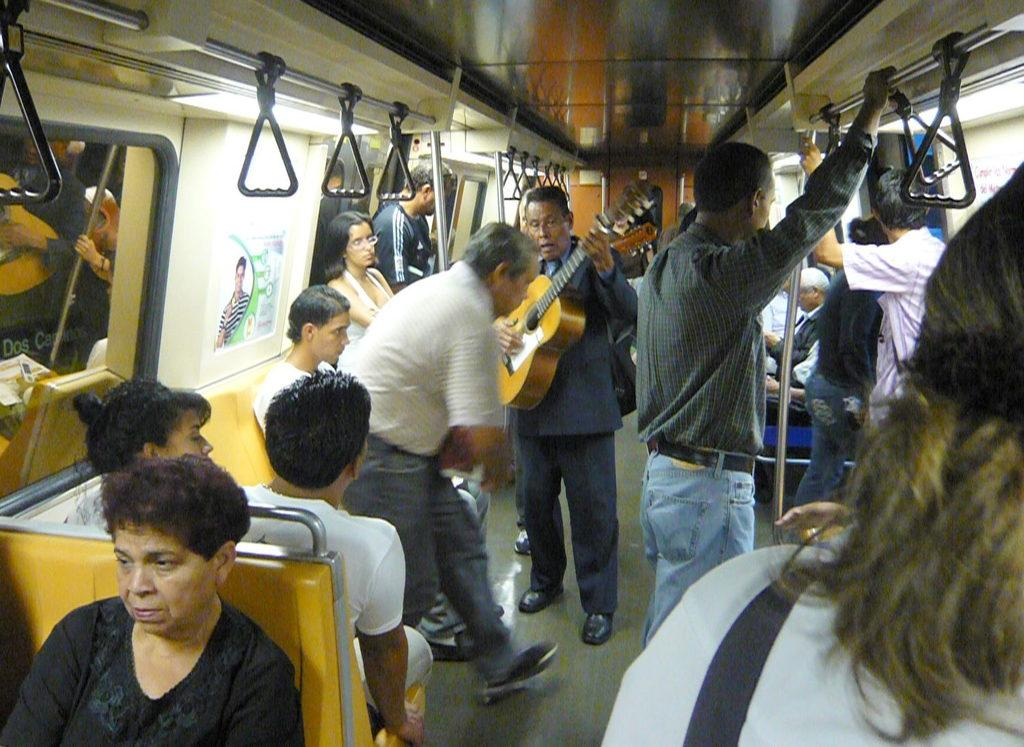What is the setting of the image? The setting of the image is a train. What are the people in the image doing? There is a group of people in the train. Is there any musical activity happening in the image? Yes, a person is playing a guitar in the train. What type of jeans is the hill wearing in the image? There is no hill or jeans present in the image; it features a group of people in a train with a person playing a guitar. 